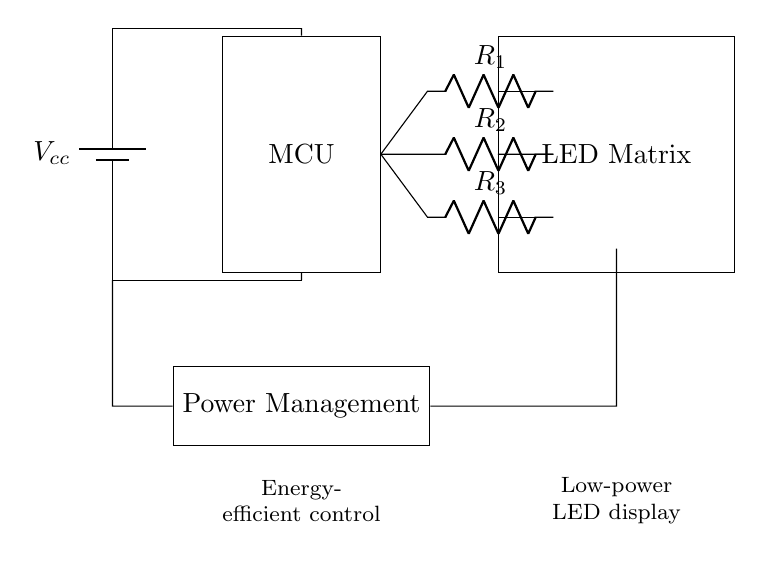What is the power supply in this circuit? The circuit diagram shows a battery labeled as Vcc, indicating that it is the power supply providing the necessary voltage for the circuit operation.
Answer: battery How many resistors are used in this circuit? The diagram depicts three resistors labeled R1, R2, and R3; hence, there are three resistors utilized in the circuit.
Answer: 3 What is the purpose of the Power Management component? The Power Management component regulates the energy flow within the circuit, ensuring that the power supply is efficiently utilized for the LED Matrix and the Microcontroller.
Answer: regulates energy flow What is the connection type between the microcontroller and the LED matrix? The connection between the microcontroller and the LED matrix is a direct connection facilitated through the resistors, which control the current going to the LEDs.
Answer: direct connection Calculate the total number of components in the circuit diagram. Counting the visible components, we have a power supply (1), microcontroller (1), LED matrix (1), power management (1), and three resistors (3), totaling six components in the circuit.
Answer: 6 Which part of the circuit manages the LED matrix power? The LED matrix power is managed by the Power Management component, which distributes the appropriate voltage and current through the resistors to ensure efficient operation of the LEDs.
Answer: Power Management What type of display technology is used in this circuit? The display technology utilized in this circuit is an LED matrix, which is specifically designed for visual output and can be controlled efficiently through the microcontroller.
Answer: LED matrix 